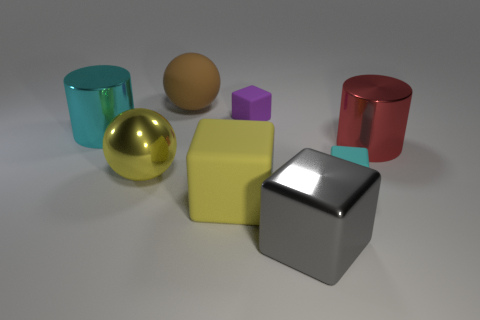Do the rubber sphere and the big shiny cylinder that is to the right of the gray metallic thing have the same color?
Keep it short and to the point. No. There is a matte object that is both behind the red metal cylinder and in front of the big brown ball; what color is it?
Provide a succinct answer. Purple. What number of large objects are to the left of the tiny cyan block?
Your answer should be compact. 5. What number of things are either large balls or big blocks behind the gray object?
Your response must be concise. 3. Are there any yellow rubber cubes to the left of the cylinder that is on the left side of the yellow rubber cube?
Ensure brevity in your answer.  No. What color is the rubber cube that is behind the cyan rubber thing?
Give a very brief answer. Purple. Are there an equal number of cubes that are in front of the gray metal object and yellow matte blocks?
Offer a terse response. No. What shape is the matte object that is behind the small cyan object and right of the big brown ball?
Provide a succinct answer. Cube. What is the color of the other big thing that is the same shape as the large red thing?
Your response must be concise. Cyan. Are there any other things that have the same color as the large rubber ball?
Your answer should be very brief. No. 